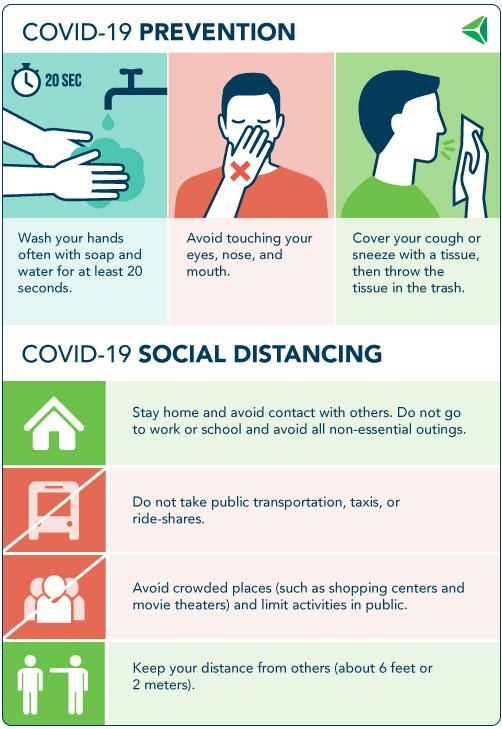Give some essential details in this illustration. For a period of 20 seconds, it is recommended that hands be thoroughly cleaned. The infographic lists 3 corona preventive measures. It is recommended to refrain from touching the eyes, nose, and mouth in order to prevent the spread of the coronavirus. 